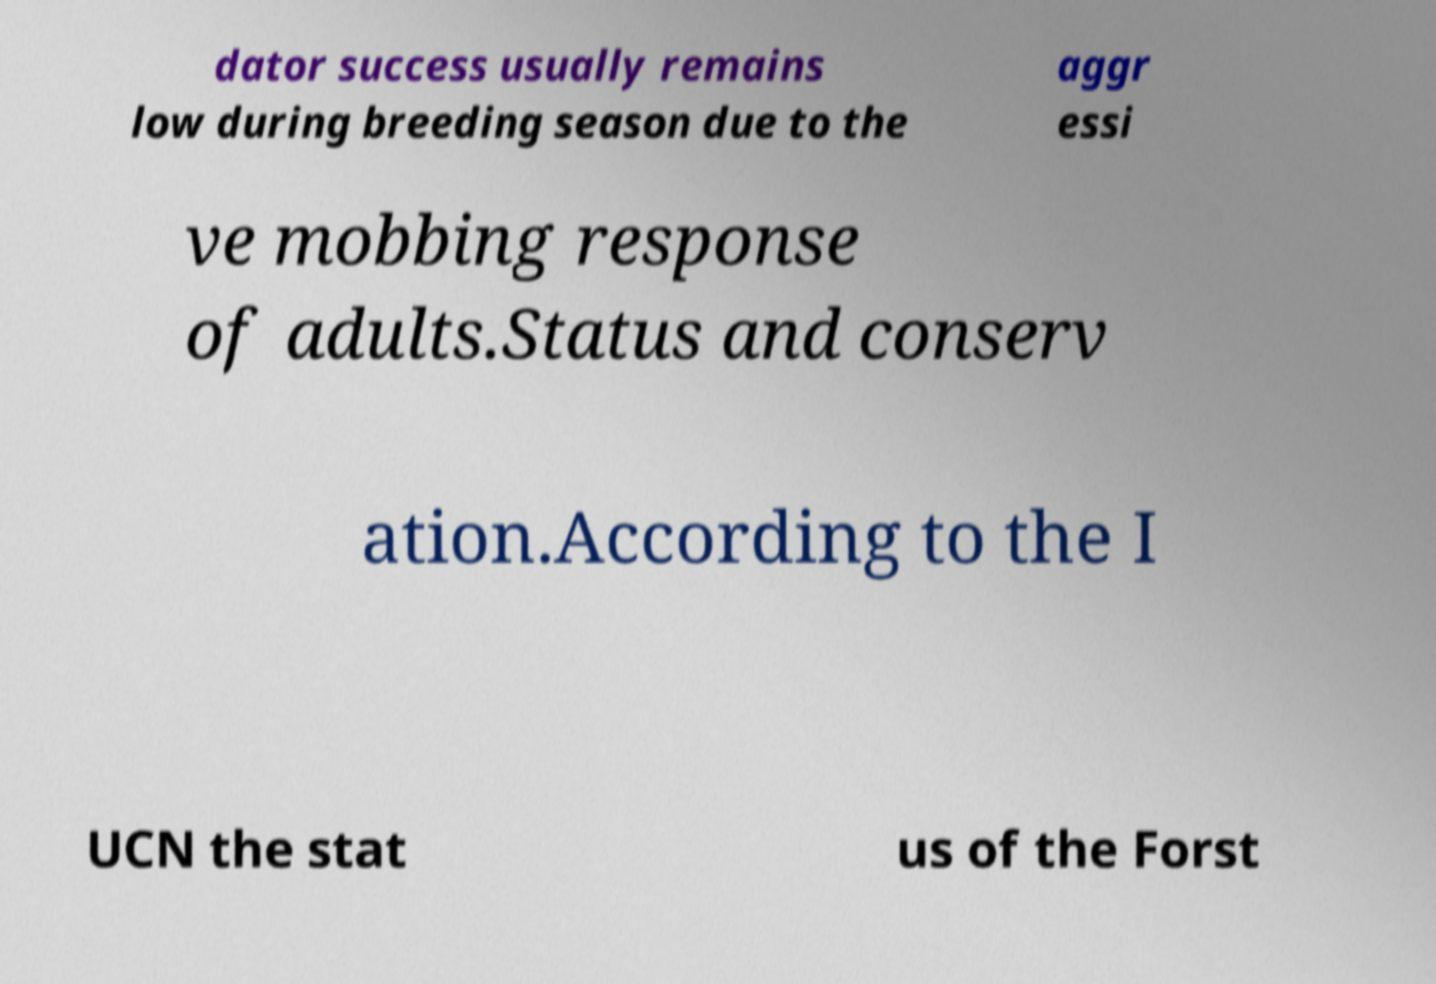Could you extract and type out the text from this image? dator success usually remains low during breeding season due to the aggr essi ve mobbing response of adults.Status and conserv ation.According to the I UCN the stat us of the Forst 